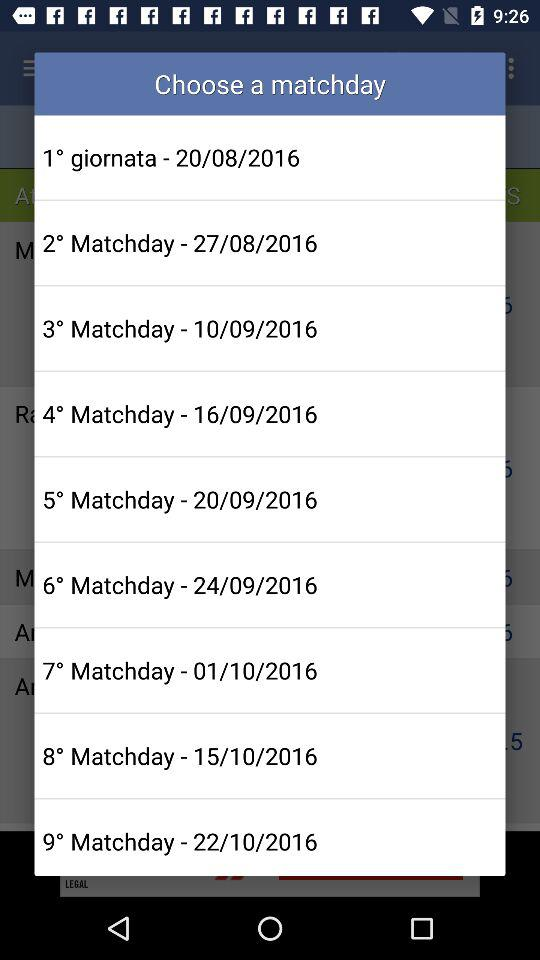How many matchdays are available?
Answer the question using a single word or phrase. 9 